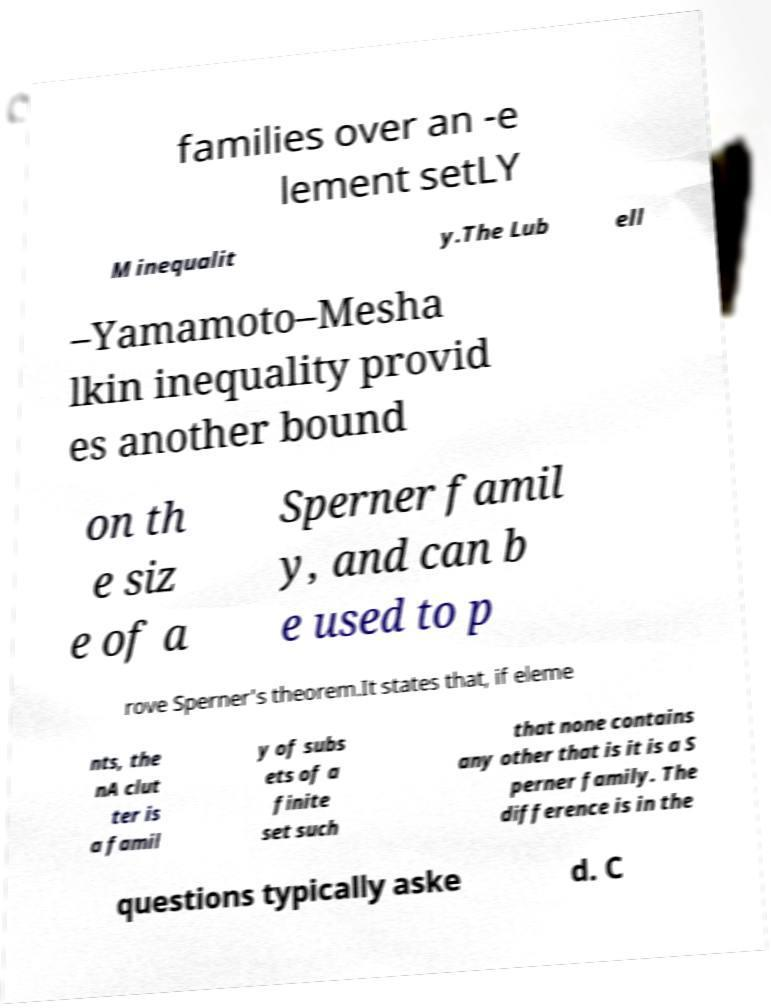Can you accurately transcribe the text from the provided image for me? families over an -e lement setLY M inequalit y.The Lub ell –Yamamoto–Mesha lkin inequality provid es another bound on th e siz e of a Sperner famil y, and can b e used to p rove Sperner's theorem.It states that, if eleme nts, the nA clut ter is a famil y of subs ets of a finite set such that none contains any other that is it is a S perner family. The difference is in the questions typically aske d. C 